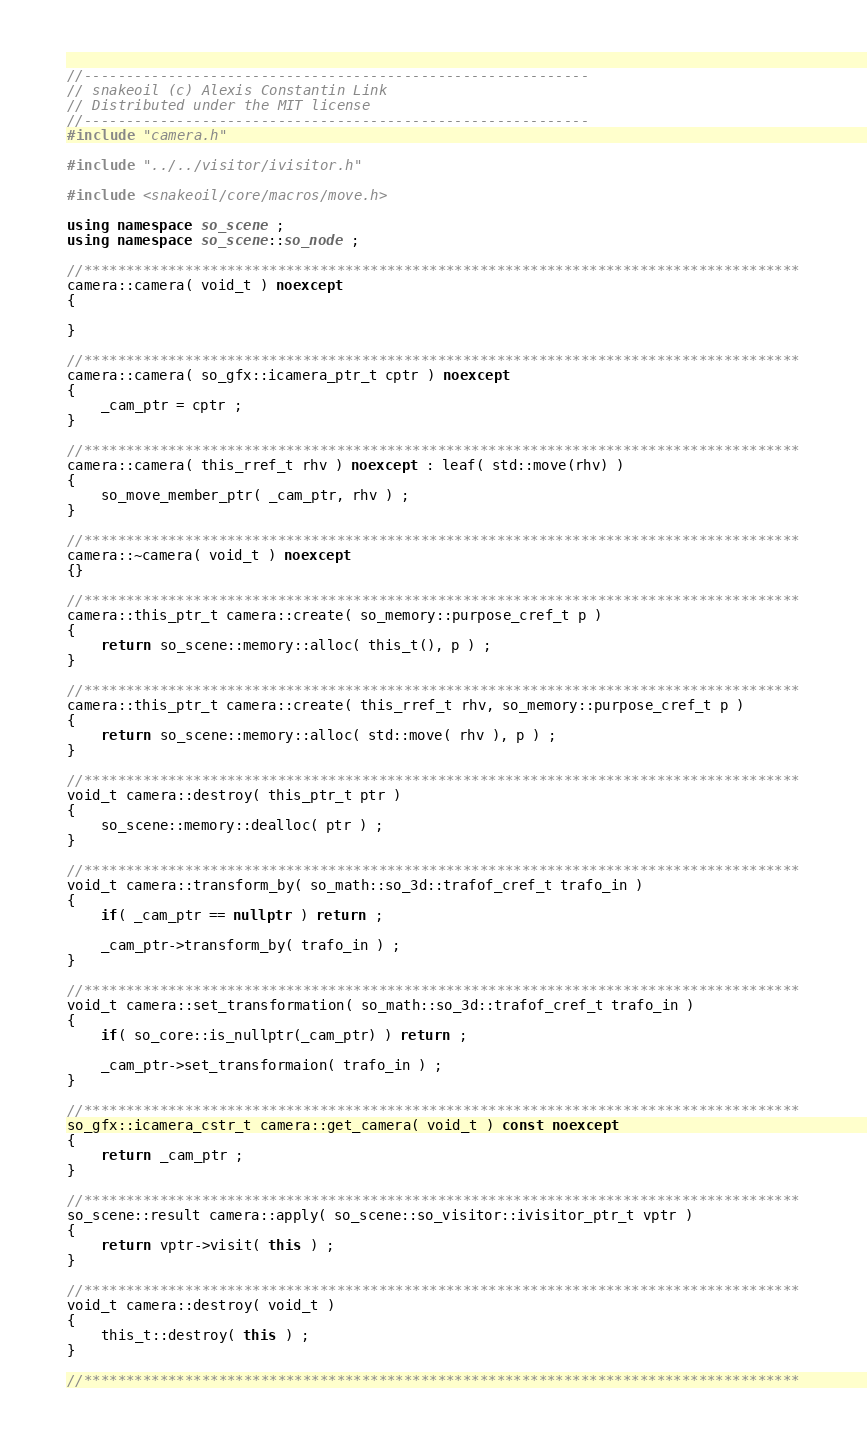Convert code to text. <code><loc_0><loc_0><loc_500><loc_500><_C++_>//------------------------------------------------------------
// snakeoil (c) Alexis Constantin Link
// Distributed under the MIT license
//------------------------------------------------------------
#include "camera.h"

#include "../../visitor/ivisitor.h"

#include <snakeoil/core/macros/move.h>

using namespace so_scene ;
using namespace so_scene::so_node ;

//*************************************************************************************
camera::camera( void_t ) noexcept
{

}

//*************************************************************************************
camera::camera( so_gfx::icamera_ptr_t cptr ) noexcept
{
    _cam_ptr = cptr ;
}

//*************************************************************************************
camera::camera( this_rref_t rhv ) noexcept : leaf( std::move(rhv) )
{
    so_move_member_ptr( _cam_ptr, rhv ) ;
}

//*************************************************************************************
camera::~camera( void_t ) noexcept
{}

//*************************************************************************************
camera::this_ptr_t camera::create( so_memory::purpose_cref_t p ) 
{
    return so_scene::memory::alloc( this_t(), p ) ;
}

//*************************************************************************************
camera::this_ptr_t camera::create( this_rref_t rhv, so_memory::purpose_cref_t p ) 
{
    return so_scene::memory::alloc( std::move( rhv ), p ) ;
}

//*************************************************************************************
void_t camera::destroy( this_ptr_t ptr ) 
{
    so_scene::memory::dealloc( ptr ) ;
}

//*************************************************************************************
void_t camera::transform_by( so_math::so_3d::trafof_cref_t trafo_in ) 
{
    if( _cam_ptr == nullptr ) return ;

    _cam_ptr->transform_by( trafo_in ) ;
}

//*************************************************************************************
void_t camera::set_transformation( so_math::so_3d::trafof_cref_t trafo_in ) 
{
    if( so_core::is_nullptr(_cam_ptr) ) return ;
    
    _cam_ptr->set_transformaion( trafo_in ) ;
}

//*************************************************************************************
so_gfx::icamera_cstr_t camera::get_camera( void_t ) const noexcept 
{
    return _cam_ptr ;
}

//*************************************************************************************
so_scene::result camera::apply( so_scene::so_visitor::ivisitor_ptr_t vptr ) 
{
    return vptr->visit( this ) ;
}

//*************************************************************************************
void_t camera::destroy( void_t )
{
    this_t::destroy( this ) ;
}

//*************************************************************************************
</code> 